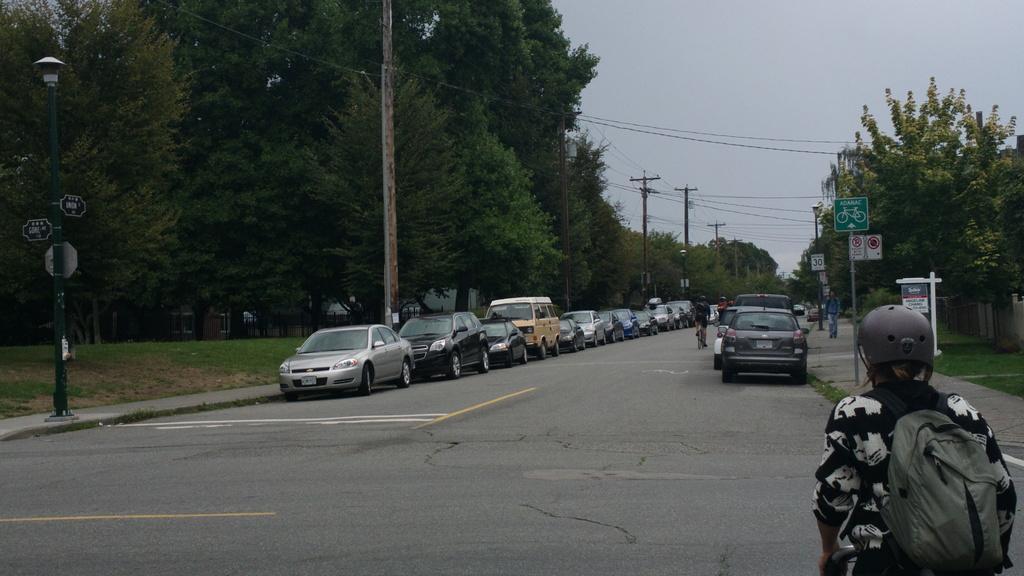Can you describe this image briefly? In the image there are cars on either side of road with a person riding bicycle in the middle and on either side of footpath there are trees with electric poles in front of them,on the right side corner there is person with helmet and bag standing and above its sky. 